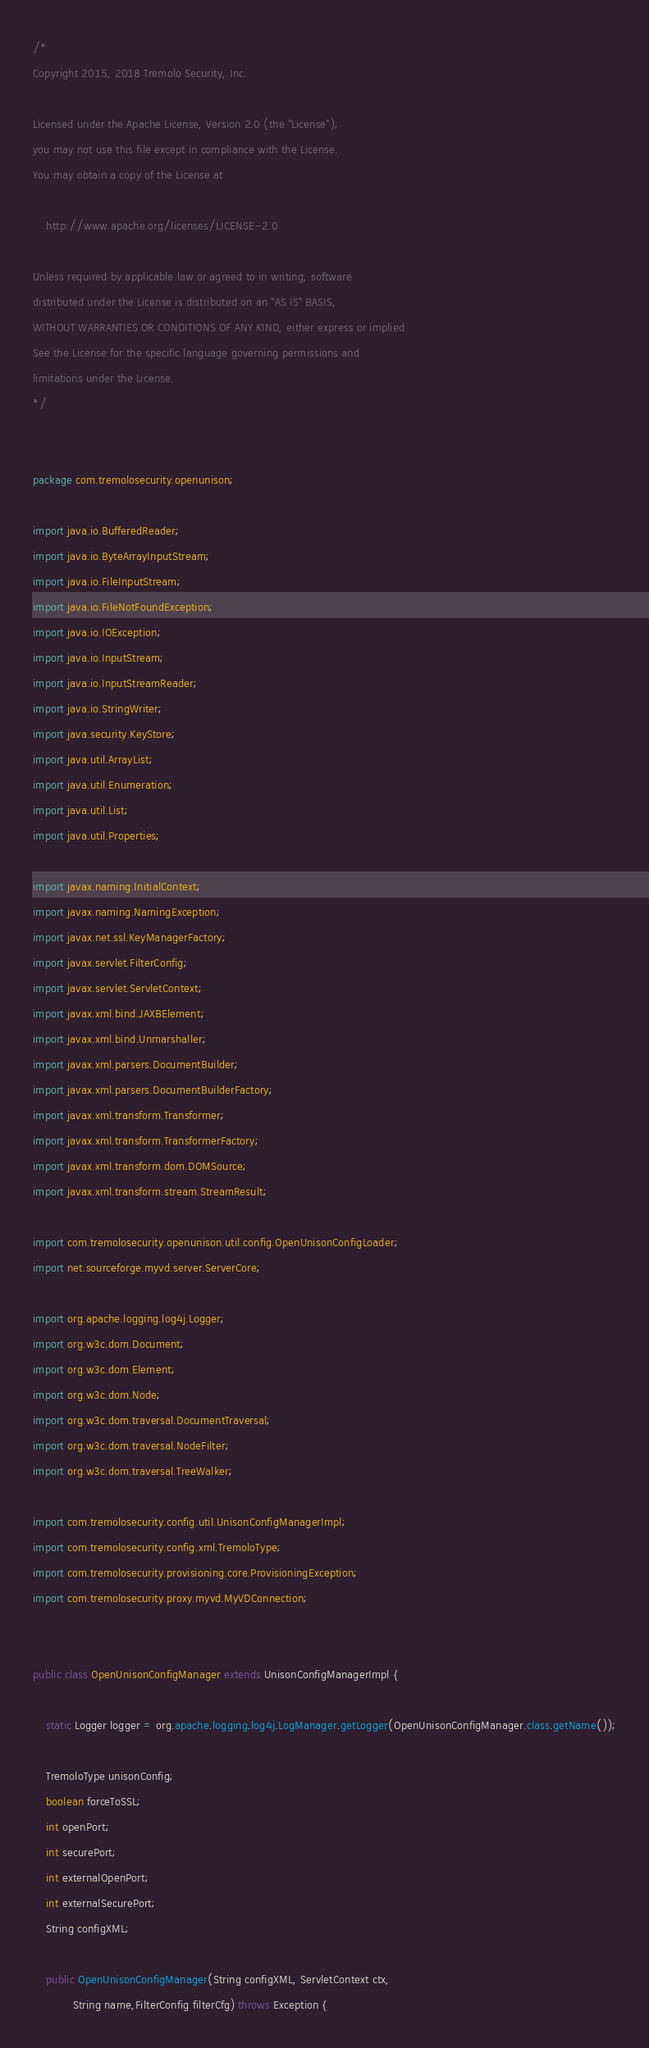Convert code to text. <code><loc_0><loc_0><loc_500><loc_500><_Java_>/*
Copyright 2015, 2018 Tremolo Security, Inc.

Licensed under the Apache License, Version 2.0 (the "License");
you may not use this file except in compliance with the License.
You may obtain a copy of the License at

    http://www.apache.org/licenses/LICENSE-2.0

Unless required by applicable law or agreed to in writing, software
distributed under the License is distributed on an "AS IS" BASIS,
WITHOUT WARRANTIES OR CONDITIONS OF ANY KIND, either express or implied.
See the License for the specific language governing permissions and
limitations under the License.
*/


package com.tremolosecurity.openunison;

import java.io.BufferedReader;
import java.io.ByteArrayInputStream;
import java.io.FileInputStream;
import java.io.FileNotFoundException;
import java.io.IOException;
import java.io.InputStream;
import java.io.InputStreamReader;
import java.io.StringWriter;
import java.security.KeyStore;
import java.util.ArrayList;
import java.util.Enumeration;
import java.util.List;
import java.util.Properties;

import javax.naming.InitialContext;
import javax.naming.NamingException;
import javax.net.ssl.KeyManagerFactory;
import javax.servlet.FilterConfig;
import javax.servlet.ServletContext;
import javax.xml.bind.JAXBElement;
import javax.xml.bind.Unmarshaller;
import javax.xml.parsers.DocumentBuilder;
import javax.xml.parsers.DocumentBuilderFactory;
import javax.xml.transform.Transformer;
import javax.xml.transform.TransformerFactory;
import javax.xml.transform.dom.DOMSource;
import javax.xml.transform.stream.StreamResult;

import com.tremolosecurity.openunison.util.config.OpenUnisonConfigLoader;
import net.sourceforge.myvd.server.ServerCore;

import org.apache.logging.log4j.Logger;
import org.w3c.dom.Document;
import org.w3c.dom.Element;
import org.w3c.dom.Node;
import org.w3c.dom.traversal.DocumentTraversal;
import org.w3c.dom.traversal.NodeFilter;
import org.w3c.dom.traversal.TreeWalker;

import com.tremolosecurity.config.util.UnisonConfigManagerImpl;
import com.tremolosecurity.config.xml.TremoloType;
import com.tremolosecurity.provisioning.core.ProvisioningException;
import com.tremolosecurity.proxy.myvd.MyVDConnection;


public class OpenUnisonConfigManager extends UnisonConfigManagerImpl {

	static Logger logger = org.apache.logging.log4j.LogManager.getLogger(OpenUnisonConfigManager.class.getName());
	
	TremoloType unisonConfig;
	boolean forceToSSL;
	int openPort;
	int securePort;
	int externalOpenPort;
	int externalSecurePort;
	String configXML;
	
	public OpenUnisonConfigManager(String configXML, ServletContext ctx,
			String name,FilterConfig filterCfg) throws Exception {</code> 